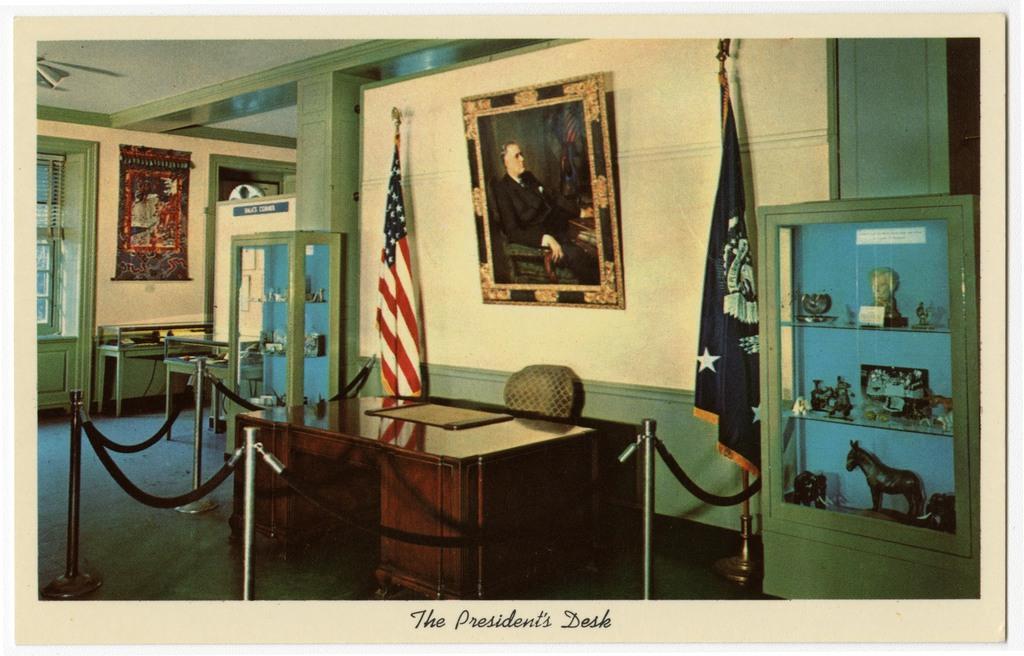Describe this image in one or two sentences. There is a table, chair, showcase, flags and a photograph in the foreground area of the image, it seems like racks, window and a poster in the background. 